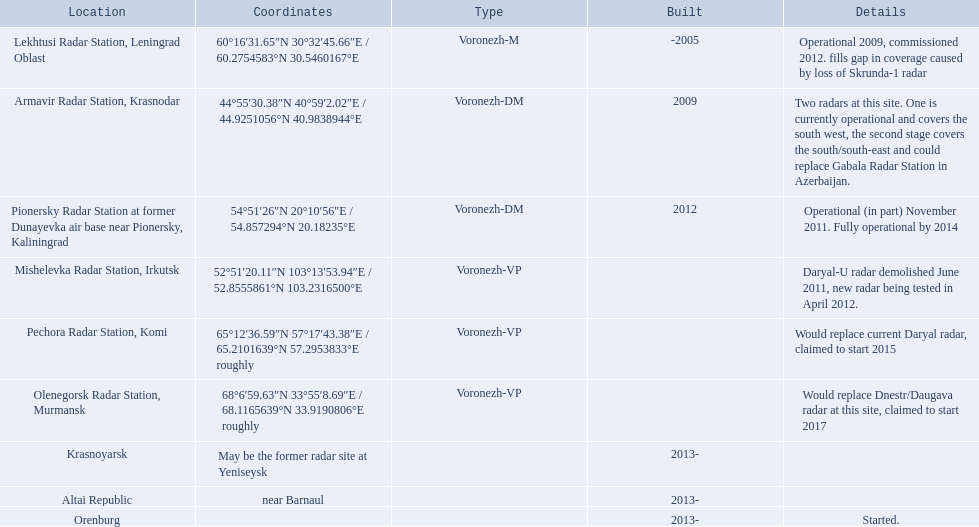What are the various locations? Lekhtusi Radar Station, Leningrad Oblast, Armavir Radar Station, Krasnodar, Pionersky Radar Station at former Dunayevka air base near Pionersky, Kaliningrad, Mishelevka Radar Station, Irkutsk, Pechora Radar Station, Komi, Olenegorsk Radar Station, Murmansk, Krasnoyarsk, Altai Republic, Orenburg. And which location has coordinates 60deg16'31.65''n 30deg32'45.66''e / 60.2754583degn 30.5460167dege? Lekhtusi Radar Station, Leningrad Oblast. 